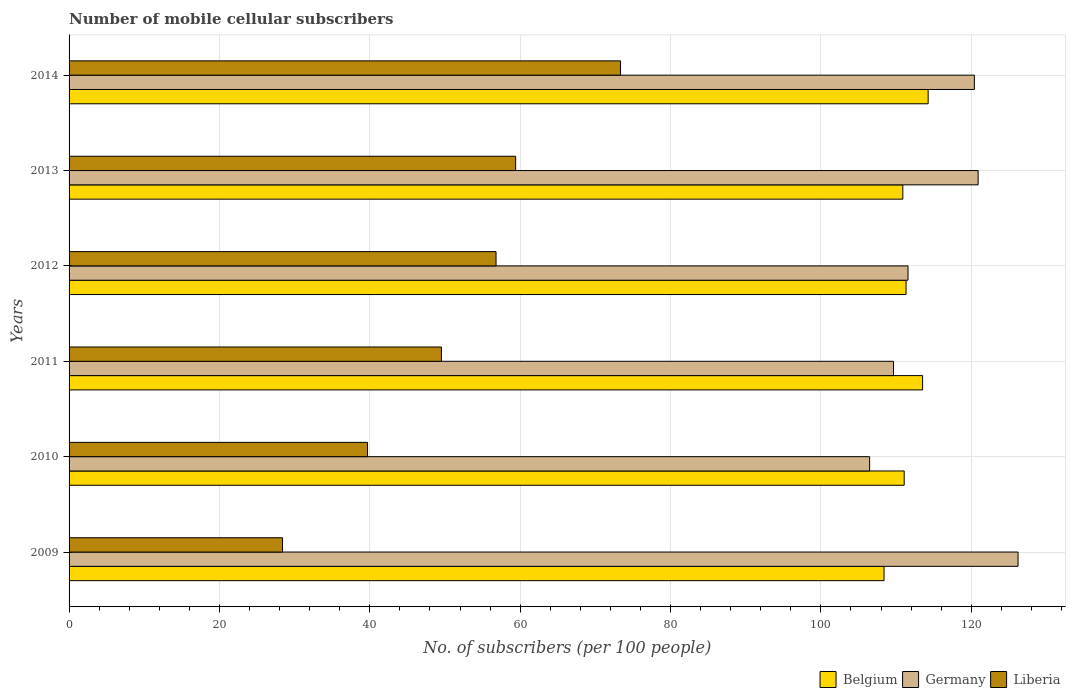How many different coloured bars are there?
Offer a very short reply. 3. How many groups of bars are there?
Make the answer very short. 6. Are the number of bars per tick equal to the number of legend labels?
Give a very brief answer. Yes. Are the number of bars on each tick of the Y-axis equal?
Ensure brevity in your answer.  Yes. What is the label of the 3rd group of bars from the top?
Provide a short and direct response. 2012. What is the number of mobile cellular subscribers in Germany in 2010?
Your answer should be compact. 106.48. Across all years, what is the maximum number of mobile cellular subscribers in Germany?
Keep it short and to the point. 126.23. Across all years, what is the minimum number of mobile cellular subscribers in Germany?
Your response must be concise. 106.48. In which year was the number of mobile cellular subscribers in Liberia minimum?
Make the answer very short. 2009. What is the total number of mobile cellular subscribers in Belgium in the graph?
Your response must be concise. 669.52. What is the difference between the number of mobile cellular subscribers in Belgium in 2009 and that in 2010?
Your answer should be very brief. -2.68. What is the difference between the number of mobile cellular subscribers in Liberia in 2009 and the number of mobile cellular subscribers in Germany in 2013?
Your answer should be very brief. -92.53. What is the average number of mobile cellular subscribers in Belgium per year?
Your response must be concise. 111.59. In the year 2009, what is the difference between the number of mobile cellular subscribers in Germany and number of mobile cellular subscribers in Belgium?
Give a very brief answer. 17.82. What is the ratio of the number of mobile cellular subscribers in Germany in 2009 to that in 2011?
Your response must be concise. 1.15. Is the number of mobile cellular subscribers in Liberia in 2012 less than that in 2013?
Ensure brevity in your answer.  Yes. What is the difference between the highest and the second highest number of mobile cellular subscribers in Belgium?
Offer a very short reply. 0.74. What is the difference between the highest and the lowest number of mobile cellular subscribers in Liberia?
Provide a short and direct response. 44.96. Is the sum of the number of mobile cellular subscribers in Belgium in 2009 and 2013 greater than the maximum number of mobile cellular subscribers in Germany across all years?
Make the answer very short. Yes. What does the 2nd bar from the bottom in 2011 represents?
Your answer should be compact. Germany. Are all the bars in the graph horizontal?
Keep it short and to the point. Yes. How many years are there in the graph?
Keep it short and to the point. 6. What is the difference between two consecutive major ticks on the X-axis?
Provide a succinct answer. 20. Are the values on the major ticks of X-axis written in scientific E-notation?
Keep it short and to the point. No. Does the graph contain any zero values?
Give a very brief answer. No. Where does the legend appear in the graph?
Keep it short and to the point. Bottom right. How many legend labels are there?
Make the answer very short. 3. How are the legend labels stacked?
Keep it short and to the point. Horizontal. What is the title of the graph?
Offer a terse response. Number of mobile cellular subscribers. Does "Mauritius" appear as one of the legend labels in the graph?
Keep it short and to the point. No. What is the label or title of the X-axis?
Your answer should be compact. No. of subscribers (per 100 people). What is the label or title of the Y-axis?
Offer a very short reply. Years. What is the No. of subscribers (per 100 people) in Belgium in 2009?
Your answer should be very brief. 108.4. What is the No. of subscribers (per 100 people) of Germany in 2009?
Offer a terse response. 126.23. What is the No. of subscribers (per 100 people) of Liberia in 2009?
Provide a short and direct response. 28.39. What is the No. of subscribers (per 100 people) in Belgium in 2010?
Offer a terse response. 111.08. What is the No. of subscribers (per 100 people) in Germany in 2010?
Provide a short and direct response. 106.48. What is the No. of subscribers (per 100 people) of Liberia in 2010?
Your answer should be very brief. 39.7. What is the No. of subscribers (per 100 people) of Belgium in 2011?
Provide a short and direct response. 113.53. What is the No. of subscribers (per 100 people) of Germany in 2011?
Offer a very short reply. 109.66. What is the No. of subscribers (per 100 people) of Liberia in 2011?
Offer a very short reply. 49.53. What is the No. of subscribers (per 100 people) in Belgium in 2012?
Ensure brevity in your answer.  111.33. What is the No. of subscribers (per 100 people) of Germany in 2012?
Ensure brevity in your answer.  111.59. What is the No. of subscribers (per 100 people) in Liberia in 2012?
Provide a short and direct response. 56.79. What is the No. of subscribers (per 100 people) in Belgium in 2013?
Your answer should be compact. 110.9. What is the No. of subscribers (per 100 people) in Germany in 2013?
Your answer should be very brief. 120.92. What is the No. of subscribers (per 100 people) of Liberia in 2013?
Your response must be concise. 59.4. What is the No. of subscribers (per 100 people) of Belgium in 2014?
Provide a succinct answer. 114.27. What is the No. of subscribers (per 100 people) of Germany in 2014?
Give a very brief answer. 120.42. What is the No. of subscribers (per 100 people) in Liberia in 2014?
Your response must be concise. 73.35. Across all years, what is the maximum No. of subscribers (per 100 people) of Belgium?
Provide a succinct answer. 114.27. Across all years, what is the maximum No. of subscribers (per 100 people) of Germany?
Give a very brief answer. 126.23. Across all years, what is the maximum No. of subscribers (per 100 people) of Liberia?
Offer a very short reply. 73.35. Across all years, what is the minimum No. of subscribers (per 100 people) of Belgium?
Your answer should be compact. 108.4. Across all years, what is the minimum No. of subscribers (per 100 people) of Germany?
Provide a short and direct response. 106.48. Across all years, what is the minimum No. of subscribers (per 100 people) of Liberia?
Provide a short and direct response. 28.39. What is the total No. of subscribers (per 100 people) of Belgium in the graph?
Provide a succinct answer. 669.52. What is the total No. of subscribers (per 100 people) in Germany in the graph?
Your answer should be very brief. 695.31. What is the total No. of subscribers (per 100 people) of Liberia in the graph?
Ensure brevity in your answer.  307.17. What is the difference between the No. of subscribers (per 100 people) in Belgium in 2009 and that in 2010?
Provide a short and direct response. -2.68. What is the difference between the No. of subscribers (per 100 people) in Germany in 2009 and that in 2010?
Provide a short and direct response. 19.74. What is the difference between the No. of subscribers (per 100 people) of Liberia in 2009 and that in 2010?
Make the answer very short. -11.31. What is the difference between the No. of subscribers (per 100 people) of Belgium in 2009 and that in 2011?
Keep it short and to the point. -5.13. What is the difference between the No. of subscribers (per 100 people) in Germany in 2009 and that in 2011?
Keep it short and to the point. 16.57. What is the difference between the No. of subscribers (per 100 people) in Liberia in 2009 and that in 2011?
Your answer should be compact. -21.14. What is the difference between the No. of subscribers (per 100 people) of Belgium in 2009 and that in 2012?
Your response must be concise. -2.93. What is the difference between the No. of subscribers (per 100 people) of Germany in 2009 and that in 2012?
Provide a short and direct response. 14.63. What is the difference between the No. of subscribers (per 100 people) of Liberia in 2009 and that in 2012?
Ensure brevity in your answer.  -28.4. What is the difference between the No. of subscribers (per 100 people) of Belgium in 2009 and that in 2013?
Your response must be concise. -2.5. What is the difference between the No. of subscribers (per 100 people) of Germany in 2009 and that in 2013?
Give a very brief answer. 5.31. What is the difference between the No. of subscribers (per 100 people) in Liberia in 2009 and that in 2013?
Offer a very short reply. -31.01. What is the difference between the No. of subscribers (per 100 people) of Belgium in 2009 and that in 2014?
Keep it short and to the point. -5.87. What is the difference between the No. of subscribers (per 100 people) in Germany in 2009 and that in 2014?
Give a very brief answer. 5.81. What is the difference between the No. of subscribers (per 100 people) in Liberia in 2009 and that in 2014?
Offer a very short reply. -44.96. What is the difference between the No. of subscribers (per 100 people) of Belgium in 2010 and that in 2011?
Your response must be concise. -2.45. What is the difference between the No. of subscribers (per 100 people) in Germany in 2010 and that in 2011?
Offer a very short reply. -3.18. What is the difference between the No. of subscribers (per 100 people) in Liberia in 2010 and that in 2011?
Provide a succinct answer. -9.83. What is the difference between the No. of subscribers (per 100 people) in Belgium in 2010 and that in 2012?
Your response must be concise. -0.25. What is the difference between the No. of subscribers (per 100 people) in Germany in 2010 and that in 2012?
Your answer should be compact. -5.11. What is the difference between the No. of subscribers (per 100 people) in Liberia in 2010 and that in 2012?
Offer a terse response. -17.09. What is the difference between the No. of subscribers (per 100 people) in Belgium in 2010 and that in 2013?
Give a very brief answer. 0.18. What is the difference between the No. of subscribers (per 100 people) of Germany in 2010 and that in 2013?
Your answer should be very brief. -14.44. What is the difference between the No. of subscribers (per 100 people) in Liberia in 2010 and that in 2013?
Your answer should be very brief. -19.7. What is the difference between the No. of subscribers (per 100 people) of Belgium in 2010 and that in 2014?
Provide a short and direct response. -3.19. What is the difference between the No. of subscribers (per 100 people) in Germany in 2010 and that in 2014?
Give a very brief answer. -13.94. What is the difference between the No. of subscribers (per 100 people) in Liberia in 2010 and that in 2014?
Give a very brief answer. -33.65. What is the difference between the No. of subscribers (per 100 people) of Belgium in 2011 and that in 2012?
Your response must be concise. 2.2. What is the difference between the No. of subscribers (per 100 people) of Germany in 2011 and that in 2012?
Keep it short and to the point. -1.93. What is the difference between the No. of subscribers (per 100 people) in Liberia in 2011 and that in 2012?
Keep it short and to the point. -7.26. What is the difference between the No. of subscribers (per 100 people) of Belgium in 2011 and that in 2013?
Your answer should be compact. 2.63. What is the difference between the No. of subscribers (per 100 people) of Germany in 2011 and that in 2013?
Your answer should be compact. -11.26. What is the difference between the No. of subscribers (per 100 people) in Liberia in 2011 and that in 2013?
Your answer should be very brief. -9.87. What is the difference between the No. of subscribers (per 100 people) in Belgium in 2011 and that in 2014?
Your answer should be very brief. -0.74. What is the difference between the No. of subscribers (per 100 people) in Germany in 2011 and that in 2014?
Your answer should be very brief. -10.76. What is the difference between the No. of subscribers (per 100 people) of Liberia in 2011 and that in 2014?
Offer a terse response. -23.82. What is the difference between the No. of subscribers (per 100 people) in Belgium in 2012 and that in 2013?
Provide a succinct answer. 0.43. What is the difference between the No. of subscribers (per 100 people) in Germany in 2012 and that in 2013?
Provide a succinct answer. -9.33. What is the difference between the No. of subscribers (per 100 people) of Liberia in 2012 and that in 2013?
Keep it short and to the point. -2.61. What is the difference between the No. of subscribers (per 100 people) in Belgium in 2012 and that in 2014?
Keep it short and to the point. -2.94. What is the difference between the No. of subscribers (per 100 people) in Germany in 2012 and that in 2014?
Provide a short and direct response. -8.82. What is the difference between the No. of subscribers (per 100 people) of Liberia in 2012 and that in 2014?
Your answer should be very brief. -16.56. What is the difference between the No. of subscribers (per 100 people) in Belgium in 2013 and that in 2014?
Your answer should be compact. -3.37. What is the difference between the No. of subscribers (per 100 people) in Germany in 2013 and that in 2014?
Keep it short and to the point. 0.5. What is the difference between the No. of subscribers (per 100 people) of Liberia in 2013 and that in 2014?
Give a very brief answer. -13.95. What is the difference between the No. of subscribers (per 100 people) of Belgium in 2009 and the No. of subscribers (per 100 people) of Germany in 2010?
Your response must be concise. 1.92. What is the difference between the No. of subscribers (per 100 people) in Belgium in 2009 and the No. of subscribers (per 100 people) in Liberia in 2010?
Keep it short and to the point. 68.7. What is the difference between the No. of subscribers (per 100 people) in Germany in 2009 and the No. of subscribers (per 100 people) in Liberia in 2010?
Your answer should be very brief. 86.53. What is the difference between the No. of subscribers (per 100 people) in Belgium in 2009 and the No. of subscribers (per 100 people) in Germany in 2011?
Your answer should be compact. -1.26. What is the difference between the No. of subscribers (per 100 people) in Belgium in 2009 and the No. of subscribers (per 100 people) in Liberia in 2011?
Offer a very short reply. 58.87. What is the difference between the No. of subscribers (per 100 people) of Germany in 2009 and the No. of subscribers (per 100 people) of Liberia in 2011?
Keep it short and to the point. 76.7. What is the difference between the No. of subscribers (per 100 people) in Belgium in 2009 and the No. of subscribers (per 100 people) in Germany in 2012?
Offer a terse response. -3.19. What is the difference between the No. of subscribers (per 100 people) in Belgium in 2009 and the No. of subscribers (per 100 people) in Liberia in 2012?
Your response must be concise. 51.61. What is the difference between the No. of subscribers (per 100 people) of Germany in 2009 and the No. of subscribers (per 100 people) of Liberia in 2012?
Ensure brevity in your answer.  69.43. What is the difference between the No. of subscribers (per 100 people) of Belgium in 2009 and the No. of subscribers (per 100 people) of Germany in 2013?
Your answer should be very brief. -12.52. What is the difference between the No. of subscribers (per 100 people) in Belgium in 2009 and the No. of subscribers (per 100 people) in Liberia in 2013?
Your answer should be compact. 49. What is the difference between the No. of subscribers (per 100 people) in Germany in 2009 and the No. of subscribers (per 100 people) in Liberia in 2013?
Offer a terse response. 66.83. What is the difference between the No. of subscribers (per 100 people) in Belgium in 2009 and the No. of subscribers (per 100 people) in Germany in 2014?
Make the answer very short. -12.02. What is the difference between the No. of subscribers (per 100 people) of Belgium in 2009 and the No. of subscribers (per 100 people) of Liberia in 2014?
Your response must be concise. 35.05. What is the difference between the No. of subscribers (per 100 people) in Germany in 2009 and the No. of subscribers (per 100 people) in Liberia in 2014?
Keep it short and to the point. 52.87. What is the difference between the No. of subscribers (per 100 people) in Belgium in 2010 and the No. of subscribers (per 100 people) in Germany in 2011?
Make the answer very short. 1.42. What is the difference between the No. of subscribers (per 100 people) of Belgium in 2010 and the No. of subscribers (per 100 people) of Liberia in 2011?
Your answer should be very brief. 61.56. What is the difference between the No. of subscribers (per 100 people) in Germany in 2010 and the No. of subscribers (per 100 people) in Liberia in 2011?
Your response must be concise. 56.95. What is the difference between the No. of subscribers (per 100 people) in Belgium in 2010 and the No. of subscribers (per 100 people) in Germany in 2012?
Your answer should be very brief. -0.51. What is the difference between the No. of subscribers (per 100 people) in Belgium in 2010 and the No. of subscribers (per 100 people) in Liberia in 2012?
Provide a short and direct response. 54.29. What is the difference between the No. of subscribers (per 100 people) in Germany in 2010 and the No. of subscribers (per 100 people) in Liberia in 2012?
Your answer should be compact. 49.69. What is the difference between the No. of subscribers (per 100 people) of Belgium in 2010 and the No. of subscribers (per 100 people) of Germany in 2013?
Ensure brevity in your answer.  -9.84. What is the difference between the No. of subscribers (per 100 people) of Belgium in 2010 and the No. of subscribers (per 100 people) of Liberia in 2013?
Offer a very short reply. 51.68. What is the difference between the No. of subscribers (per 100 people) of Germany in 2010 and the No. of subscribers (per 100 people) of Liberia in 2013?
Offer a very short reply. 47.08. What is the difference between the No. of subscribers (per 100 people) in Belgium in 2010 and the No. of subscribers (per 100 people) in Germany in 2014?
Make the answer very short. -9.33. What is the difference between the No. of subscribers (per 100 people) of Belgium in 2010 and the No. of subscribers (per 100 people) of Liberia in 2014?
Provide a short and direct response. 37.73. What is the difference between the No. of subscribers (per 100 people) of Germany in 2010 and the No. of subscribers (per 100 people) of Liberia in 2014?
Make the answer very short. 33.13. What is the difference between the No. of subscribers (per 100 people) in Belgium in 2011 and the No. of subscribers (per 100 people) in Germany in 2012?
Provide a succinct answer. 1.94. What is the difference between the No. of subscribers (per 100 people) in Belgium in 2011 and the No. of subscribers (per 100 people) in Liberia in 2012?
Give a very brief answer. 56.74. What is the difference between the No. of subscribers (per 100 people) in Germany in 2011 and the No. of subscribers (per 100 people) in Liberia in 2012?
Ensure brevity in your answer.  52.87. What is the difference between the No. of subscribers (per 100 people) of Belgium in 2011 and the No. of subscribers (per 100 people) of Germany in 2013?
Keep it short and to the point. -7.39. What is the difference between the No. of subscribers (per 100 people) of Belgium in 2011 and the No. of subscribers (per 100 people) of Liberia in 2013?
Make the answer very short. 54.13. What is the difference between the No. of subscribers (per 100 people) of Germany in 2011 and the No. of subscribers (per 100 people) of Liberia in 2013?
Your response must be concise. 50.26. What is the difference between the No. of subscribers (per 100 people) in Belgium in 2011 and the No. of subscribers (per 100 people) in Germany in 2014?
Offer a very short reply. -6.89. What is the difference between the No. of subscribers (per 100 people) of Belgium in 2011 and the No. of subscribers (per 100 people) of Liberia in 2014?
Give a very brief answer. 40.18. What is the difference between the No. of subscribers (per 100 people) in Germany in 2011 and the No. of subscribers (per 100 people) in Liberia in 2014?
Offer a terse response. 36.31. What is the difference between the No. of subscribers (per 100 people) of Belgium in 2012 and the No. of subscribers (per 100 people) of Germany in 2013?
Give a very brief answer. -9.59. What is the difference between the No. of subscribers (per 100 people) in Belgium in 2012 and the No. of subscribers (per 100 people) in Liberia in 2013?
Your answer should be very brief. 51.93. What is the difference between the No. of subscribers (per 100 people) of Germany in 2012 and the No. of subscribers (per 100 people) of Liberia in 2013?
Offer a terse response. 52.19. What is the difference between the No. of subscribers (per 100 people) in Belgium in 2012 and the No. of subscribers (per 100 people) in Germany in 2014?
Make the answer very short. -9.09. What is the difference between the No. of subscribers (per 100 people) in Belgium in 2012 and the No. of subscribers (per 100 people) in Liberia in 2014?
Offer a terse response. 37.98. What is the difference between the No. of subscribers (per 100 people) of Germany in 2012 and the No. of subscribers (per 100 people) of Liberia in 2014?
Keep it short and to the point. 38.24. What is the difference between the No. of subscribers (per 100 people) in Belgium in 2013 and the No. of subscribers (per 100 people) in Germany in 2014?
Offer a terse response. -9.52. What is the difference between the No. of subscribers (per 100 people) of Belgium in 2013 and the No. of subscribers (per 100 people) of Liberia in 2014?
Provide a succinct answer. 37.55. What is the difference between the No. of subscribers (per 100 people) in Germany in 2013 and the No. of subscribers (per 100 people) in Liberia in 2014?
Make the answer very short. 47.57. What is the average No. of subscribers (per 100 people) in Belgium per year?
Ensure brevity in your answer.  111.59. What is the average No. of subscribers (per 100 people) of Germany per year?
Provide a short and direct response. 115.88. What is the average No. of subscribers (per 100 people) of Liberia per year?
Provide a succinct answer. 51.2. In the year 2009, what is the difference between the No. of subscribers (per 100 people) of Belgium and No. of subscribers (per 100 people) of Germany?
Give a very brief answer. -17.82. In the year 2009, what is the difference between the No. of subscribers (per 100 people) in Belgium and No. of subscribers (per 100 people) in Liberia?
Keep it short and to the point. 80.01. In the year 2009, what is the difference between the No. of subscribers (per 100 people) of Germany and No. of subscribers (per 100 people) of Liberia?
Your response must be concise. 97.83. In the year 2010, what is the difference between the No. of subscribers (per 100 people) in Belgium and No. of subscribers (per 100 people) in Germany?
Provide a short and direct response. 4.6. In the year 2010, what is the difference between the No. of subscribers (per 100 people) in Belgium and No. of subscribers (per 100 people) in Liberia?
Ensure brevity in your answer.  71.38. In the year 2010, what is the difference between the No. of subscribers (per 100 people) of Germany and No. of subscribers (per 100 people) of Liberia?
Provide a succinct answer. 66.78. In the year 2011, what is the difference between the No. of subscribers (per 100 people) in Belgium and No. of subscribers (per 100 people) in Germany?
Ensure brevity in your answer.  3.87. In the year 2011, what is the difference between the No. of subscribers (per 100 people) in Belgium and No. of subscribers (per 100 people) in Liberia?
Offer a terse response. 64. In the year 2011, what is the difference between the No. of subscribers (per 100 people) in Germany and No. of subscribers (per 100 people) in Liberia?
Keep it short and to the point. 60.13. In the year 2012, what is the difference between the No. of subscribers (per 100 people) in Belgium and No. of subscribers (per 100 people) in Germany?
Your response must be concise. -0.26. In the year 2012, what is the difference between the No. of subscribers (per 100 people) in Belgium and No. of subscribers (per 100 people) in Liberia?
Provide a short and direct response. 54.54. In the year 2012, what is the difference between the No. of subscribers (per 100 people) of Germany and No. of subscribers (per 100 people) of Liberia?
Offer a terse response. 54.8. In the year 2013, what is the difference between the No. of subscribers (per 100 people) in Belgium and No. of subscribers (per 100 people) in Germany?
Make the answer very short. -10.02. In the year 2013, what is the difference between the No. of subscribers (per 100 people) in Belgium and No. of subscribers (per 100 people) in Liberia?
Offer a very short reply. 51.5. In the year 2013, what is the difference between the No. of subscribers (per 100 people) of Germany and No. of subscribers (per 100 people) of Liberia?
Provide a short and direct response. 61.52. In the year 2014, what is the difference between the No. of subscribers (per 100 people) in Belgium and No. of subscribers (per 100 people) in Germany?
Give a very brief answer. -6.15. In the year 2014, what is the difference between the No. of subscribers (per 100 people) of Belgium and No. of subscribers (per 100 people) of Liberia?
Ensure brevity in your answer.  40.92. In the year 2014, what is the difference between the No. of subscribers (per 100 people) in Germany and No. of subscribers (per 100 people) in Liberia?
Ensure brevity in your answer.  47.07. What is the ratio of the No. of subscribers (per 100 people) of Belgium in 2009 to that in 2010?
Your answer should be compact. 0.98. What is the ratio of the No. of subscribers (per 100 people) in Germany in 2009 to that in 2010?
Provide a short and direct response. 1.19. What is the ratio of the No. of subscribers (per 100 people) in Liberia in 2009 to that in 2010?
Make the answer very short. 0.72. What is the ratio of the No. of subscribers (per 100 people) of Belgium in 2009 to that in 2011?
Your answer should be very brief. 0.95. What is the ratio of the No. of subscribers (per 100 people) in Germany in 2009 to that in 2011?
Provide a short and direct response. 1.15. What is the ratio of the No. of subscribers (per 100 people) of Liberia in 2009 to that in 2011?
Ensure brevity in your answer.  0.57. What is the ratio of the No. of subscribers (per 100 people) in Belgium in 2009 to that in 2012?
Keep it short and to the point. 0.97. What is the ratio of the No. of subscribers (per 100 people) of Germany in 2009 to that in 2012?
Make the answer very short. 1.13. What is the ratio of the No. of subscribers (per 100 people) in Liberia in 2009 to that in 2012?
Provide a short and direct response. 0.5. What is the ratio of the No. of subscribers (per 100 people) in Belgium in 2009 to that in 2013?
Your answer should be compact. 0.98. What is the ratio of the No. of subscribers (per 100 people) in Germany in 2009 to that in 2013?
Keep it short and to the point. 1.04. What is the ratio of the No. of subscribers (per 100 people) of Liberia in 2009 to that in 2013?
Provide a succinct answer. 0.48. What is the ratio of the No. of subscribers (per 100 people) in Belgium in 2009 to that in 2014?
Ensure brevity in your answer.  0.95. What is the ratio of the No. of subscribers (per 100 people) in Germany in 2009 to that in 2014?
Your answer should be very brief. 1.05. What is the ratio of the No. of subscribers (per 100 people) of Liberia in 2009 to that in 2014?
Your answer should be very brief. 0.39. What is the ratio of the No. of subscribers (per 100 people) in Belgium in 2010 to that in 2011?
Your response must be concise. 0.98. What is the ratio of the No. of subscribers (per 100 people) of Liberia in 2010 to that in 2011?
Give a very brief answer. 0.8. What is the ratio of the No. of subscribers (per 100 people) of Belgium in 2010 to that in 2012?
Make the answer very short. 1. What is the ratio of the No. of subscribers (per 100 people) in Germany in 2010 to that in 2012?
Make the answer very short. 0.95. What is the ratio of the No. of subscribers (per 100 people) in Liberia in 2010 to that in 2012?
Your answer should be very brief. 0.7. What is the ratio of the No. of subscribers (per 100 people) of Germany in 2010 to that in 2013?
Make the answer very short. 0.88. What is the ratio of the No. of subscribers (per 100 people) in Liberia in 2010 to that in 2013?
Give a very brief answer. 0.67. What is the ratio of the No. of subscribers (per 100 people) of Belgium in 2010 to that in 2014?
Provide a succinct answer. 0.97. What is the ratio of the No. of subscribers (per 100 people) in Germany in 2010 to that in 2014?
Your answer should be very brief. 0.88. What is the ratio of the No. of subscribers (per 100 people) in Liberia in 2010 to that in 2014?
Keep it short and to the point. 0.54. What is the ratio of the No. of subscribers (per 100 people) of Belgium in 2011 to that in 2012?
Your response must be concise. 1.02. What is the ratio of the No. of subscribers (per 100 people) of Germany in 2011 to that in 2012?
Your answer should be very brief. 0.98. What is the ratio of the No. of subscribers (per 100 people) of Liberia in 2011 to that in 2012?
Offer a very short reply. 0.87. What is the ratio of the No. of subscribers (per 100 people) in Belgium in 2011 to that in 2013?
Offer a very short reply. 1.02. What is the ratio of the No. of subscribers (per 100 people) of Germany in 2011 to that in 2013?
Keep it short and to the point. 0.91. What is the ratio of the No. of subscribers (per 100 people) of Liberia in 2011 to that in 2013?
Your response must be concise. 0.83. What is the ratio of the No. of subscribers (per 100 people) of Belgium in 2011 to that in 2014?
Offer a terse response. 0.99. What is the ratio of the No. of subscribers (per 100 people) in Germany in 2011 to that in 2014?
Ensure brevity in your answer.  0.91. What is the ratio of the No. of subscribers (per 100 people) in Liberia in 2011 to that in 2014?
Make the answer very short. 0.68. What is the ratio of the No. of subscribers (per 100 people) in Germany in 2012 to that in 2013?
Give a very brief answer. 0.92. What is the ratio of the No. of subscribers (per 100 people) of Liberia in 2012 to that in 2013?
Offer a terse response. 0.96. What is the ratio of the No. of subscribers (per 100 people) in Belgium in 2012 to that in 2014?
Make the answer very short. 0.97. What is the ratio of the No. of subscribers (per 100 people) of Germany in 2012 to that in 2014?
Provide a succinct answer. 0.93. What is the ratio of the No. of subscribers (per 100 people) in Liberia in 2012 to that in 2014?
Keep it short and to the point. 0.77. What is the ratio of the No. of subscribers (per 100 people) in Belgium in 2013 to that in 2014?
Offer a terse response. 0.97. What is the ratio of the No. of subscribers (per 100 people) in Liberia in 2013 to that in 2014?
Ensure brevity in your answer.  0.81. What is the difference between the highest and the second highest No. of subscribers (per 100 people) in Belgium?
Make the answer very short. 0.74. What is the difference between the highest and the second highest No. of subscribers (per 100 people) of Germany?
Give a very brief answer. 5.31. What is the difference between the highest and the second highest No. of subscribers (per 100 people) of Liberia?
Your response must be concise. 13.95. What is the difference between the highest and the lowest No. of subscribers (per 100 people) of Belgium?
Your answer should be very brief. 5.87. What is the difference between the highest and the lowest No. of subscribers (per 100 people) in Germany?
Your answer should be very brief. 19.74. What is the difference between the highest and the lowest No. of subscribers (per 100 people) in Liberia?
Provide a succinct answer. 44.96. 